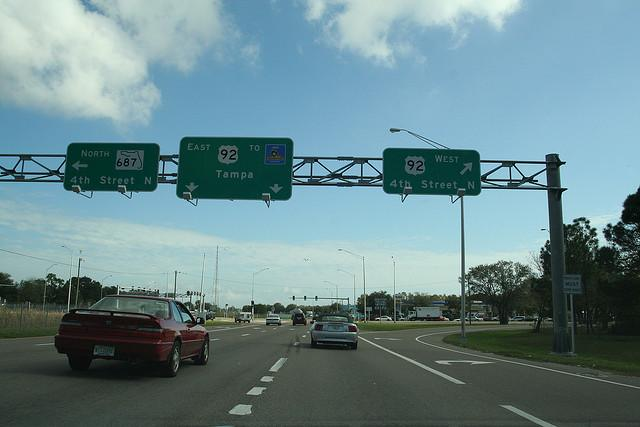What is the right lane used for? turning 